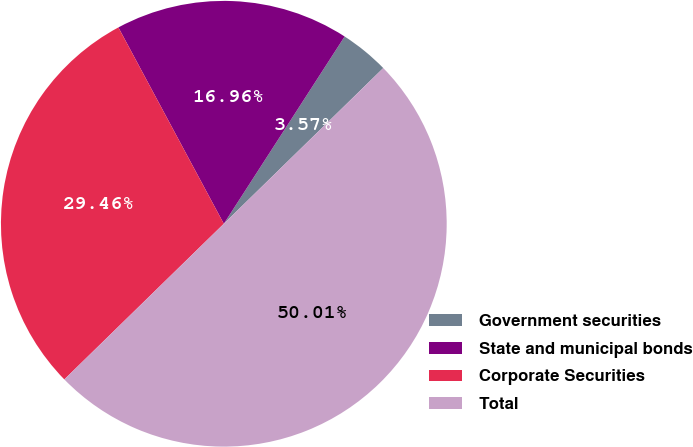<chart> <loc_0><loc_0><loc_500><loc_500><pie_chart><fcel>Government securities<fcel>State and municipal bonds<fcel>Corporate Securities<fcel>Total<nl><fcel>3.57%<fcel>16.96%<fcel>29.46%<fcel>50.0%<nl></chart> 